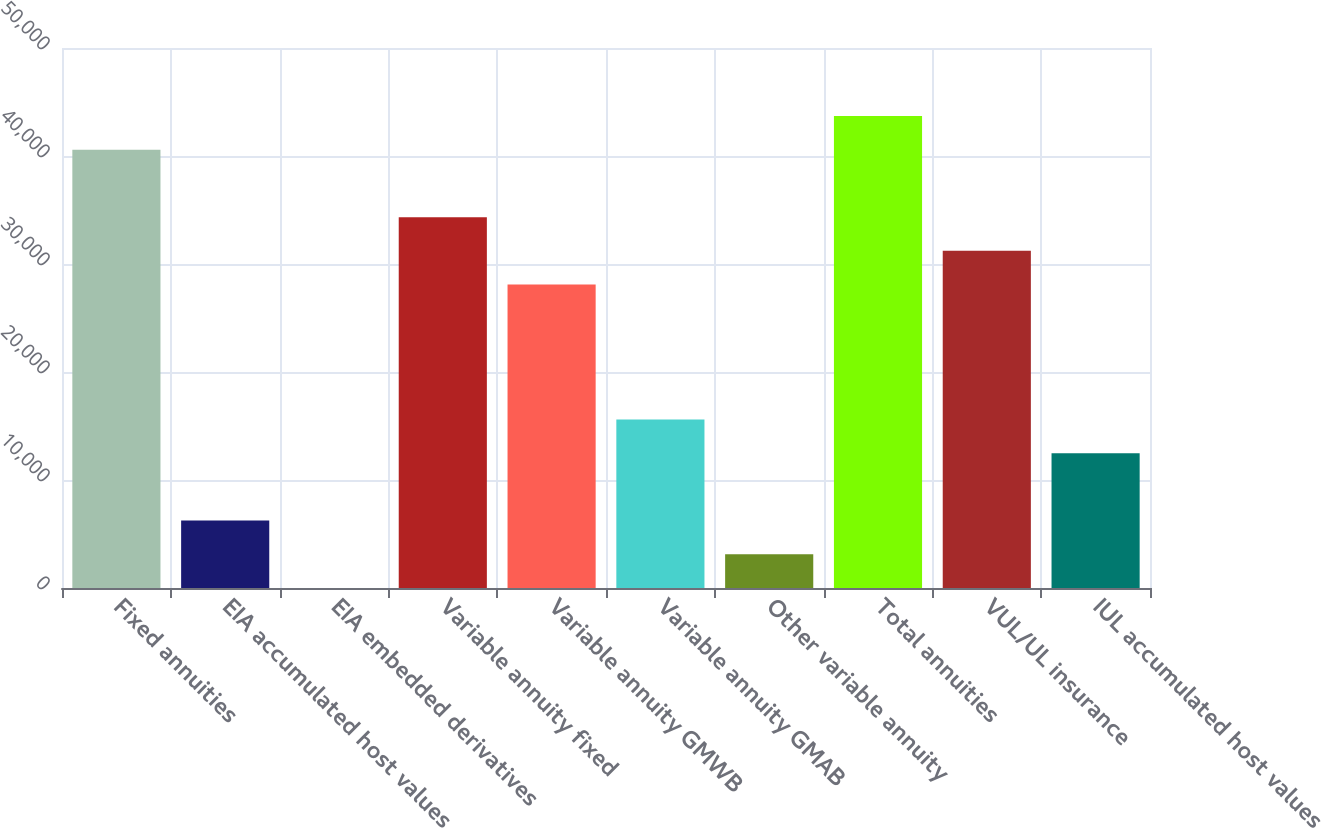<chart> <loc_0><loc_0><loc_500><loc_500><bar_chart><fcel>Fixed annuities<fcel>EIA accumulated host values<fcel>EIA embedded derivatives<fcel>Variable annuity fixed<fcel>Variable annuity GMWB<fcel>Variable annuity GMAB<fcel>Other variable annuity<fcel>Total annuities<fcel>VUL/UL insurance<fcel>IUL accumulated host values<nl><fcel>40581.5<fcel>6245<fcel>2<fcel>34338.5<fcel>28095.5<fcel>15609.5<fcel>3123.5<fcel>43703<fcel>31217<fcel>12488<nl></chart> 